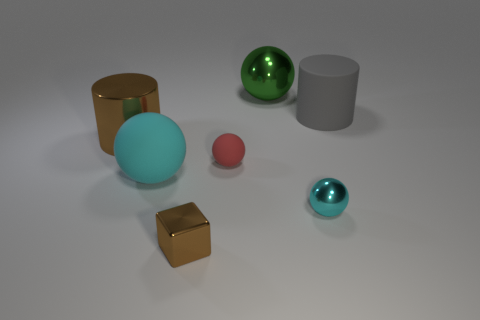Are there fewer brown objects than things?
Offer a very short reply. Yes. What is the color of the metal object that is to the left of the tiny red rubber thing and behind the red rubber object?
Provide a succinct answer. Brown. There is a large green thing that is the same shape as the red object; what is it made of?
Ensure brevity in your answer.  Metal. Are there more tiny brown metal blocks than red cylinders?
Offer a very short reply. Yes. What size is the ball that is on the right side of the small rubber ball and behind the small shiny sphere?
Your answer should be very brief. Large. The gray thing has what shape?
Give a very brief answer. Cylinder. How many red things are the same shape as the tiny brown object?
Your answer should be very brief. 0. Are there fewer big brown shiny things in front of the red rubber ball than large metal things that are to the left of the green ball?
Offer a terse response. Yes. What number of small red rubber spheres are left of the large sphere that is in front of the large green object?
Offer a very short reply. 0. Is there a big rubber thing?
Provide a succinct answer. Yes. 